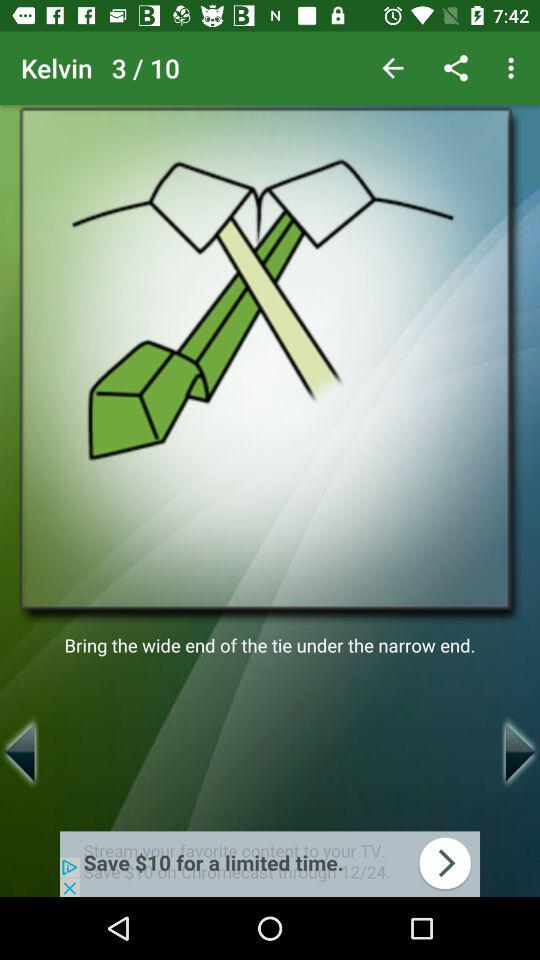What is the current image number? The current image number is 3. 